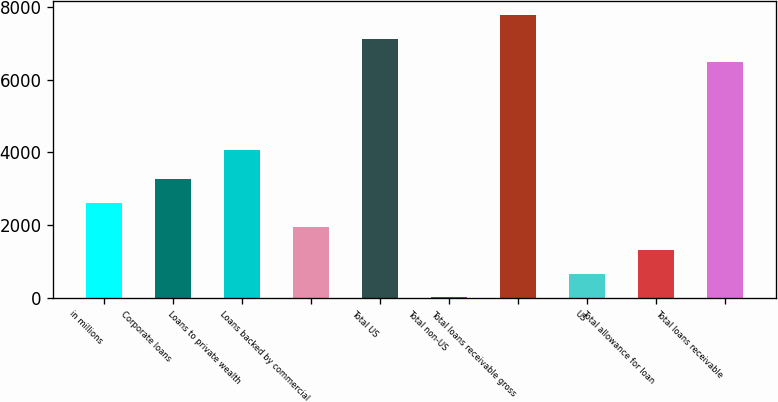Convert chart. <chart><loc_0><loc_0><loc_500><loc_500><bar_chart><fcel>in millions<fcel>Corporate loans<fcel>Loans to private wealth<fcel>Loans backed by commercial<fcel>Total US<fcel>Total non-US<fcel>Total loans receivable gross<fcel>US<fcel>Total allowance for loan<fcel>Total loans receivable<nl><fcel>2609.6<fcel>3258.5<fcel>4057<fcel>1960.7<fcel>7127.9<fcel>14<fcel>7776.8<fcel>662.9<fcel>1311.8<fcel>6479<nl></chart> 